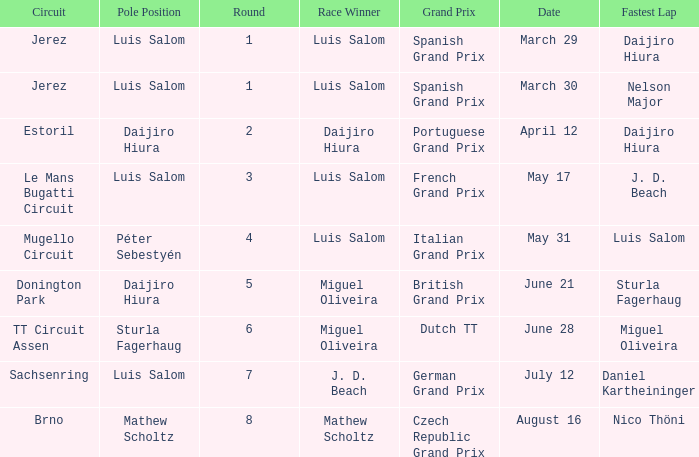Could you help me parse every detail presented in this table? {'header': ['Circuit', 'Pole Position', 'Round', 'Race Winner', 'Grand Prix', 'Date', 'Fastest Lap'], 'rows': [['Jerez', 'Luis Salom', '1', 'Luis Salom', 'Spanish Grand Prix', 'March 29', 'Daijiro Hiura'], ['Jerez', 'Luis Salom', '1', 'Luis Salom', 'Spanish Grand Prix', 'March 30', 'Nelson Major'], ['Estoril', 'Daijiro Hiura', '2', 'Daijiro Hiura', 'Portuguese Grand Prix', 'April 12', 'Daijiro Hiura'], ['Le Mans Bugatti Circuit', 'Luis Salom', '3', 'Luis Salom', 'French Grand Prix', 'May 17', 'J. D. Beach'], ['Mugello Circuit', 'Péter Sebestyén', '4', 'Luis Salom', 'Italian Grand Prix', 'May 31', 'Luis Salom'], ['Donington Park', 'Daijiro Hiura', '5', 'Miguel Oliveira', 'British Grand Prix', 'June 21', 'Sturla Fagerhaug'], ['TT Circuit Assen', 'Sturla Fagerhaug', '6', 'Miguel Oliveira', 'Dutch TT', 'June 28', 'Miguel Oliveira'], ['Sachsenring', 'Luis Salom', '7', 'J. D. Beach', 'German Grand Prix', 'July 12', 'Daniel Kartheininger'], ['Brno', 'Mathew Scholtz', '8', 'Mathew Scholtz', 'Czech Republic Grand Prix', 'August 16', 'Nico Thöni']]} Who had the fastest lap in the Dutch TT Grand Prix?  Miguel Oliveira. 